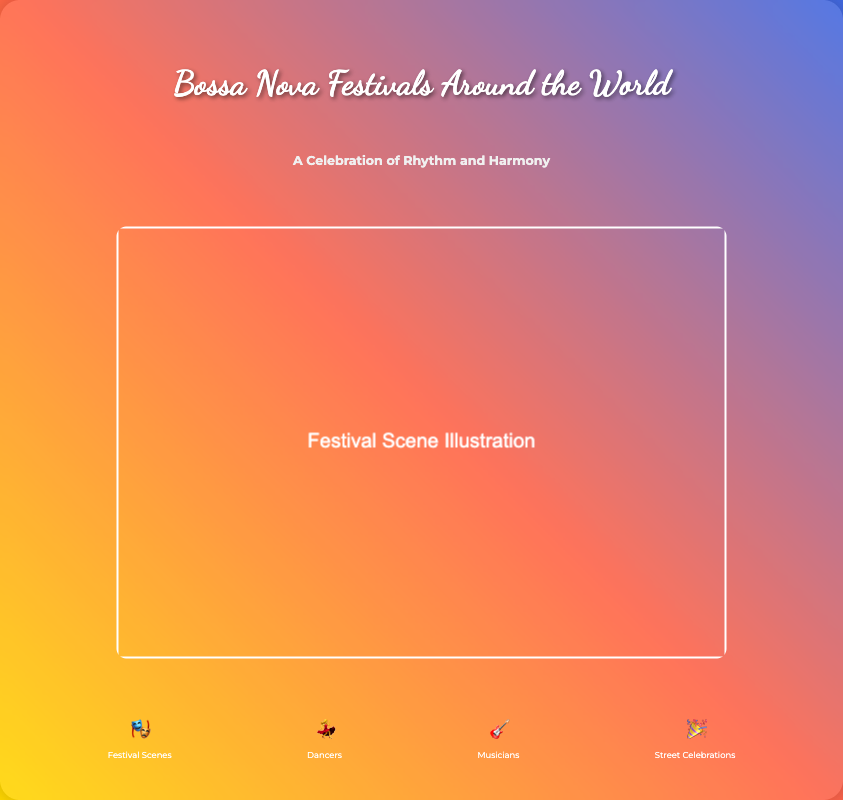What is the title of the book? The title is prominently displayed in a large font at the top of the cover.
Answer: Bossa Nova Festivals Around the World What is the subtitle of the book? The subtitle is located directly beneath the title and encapsulates the theme of the book.
Answer: A Celebration of Rhythm and Harmony What is depicted in the cover image? The cover image visually represents the theme of the book and includes an illustration related to festivals.
Answer: Festival Scene Illustration How many elements are highlighted on the cover? The elements section lists specific aspects of the festivals.
Answer: Four What emoji represents dancers? The icons used in the elements section correspond to different aspects of the festival.
Answer: 💃 What does the icon with the 🎉 represent? Each icon is associated with a specific category related to the festivals discussed in the book.
Answer: Street Celebrations What colors dominate the background of the book cover? The background features a gradient of various bright colors to capture the festive essence.
Answer: Gold, red, blue What font is used for the title? The title uses a distinctive font that adds character and a festive vibe to the cover.
Answer: Dancing Script Which section describes musicians? Each category is clearly labeled, and this section highlights those who play music at the festivals.
Answer: Musicians 